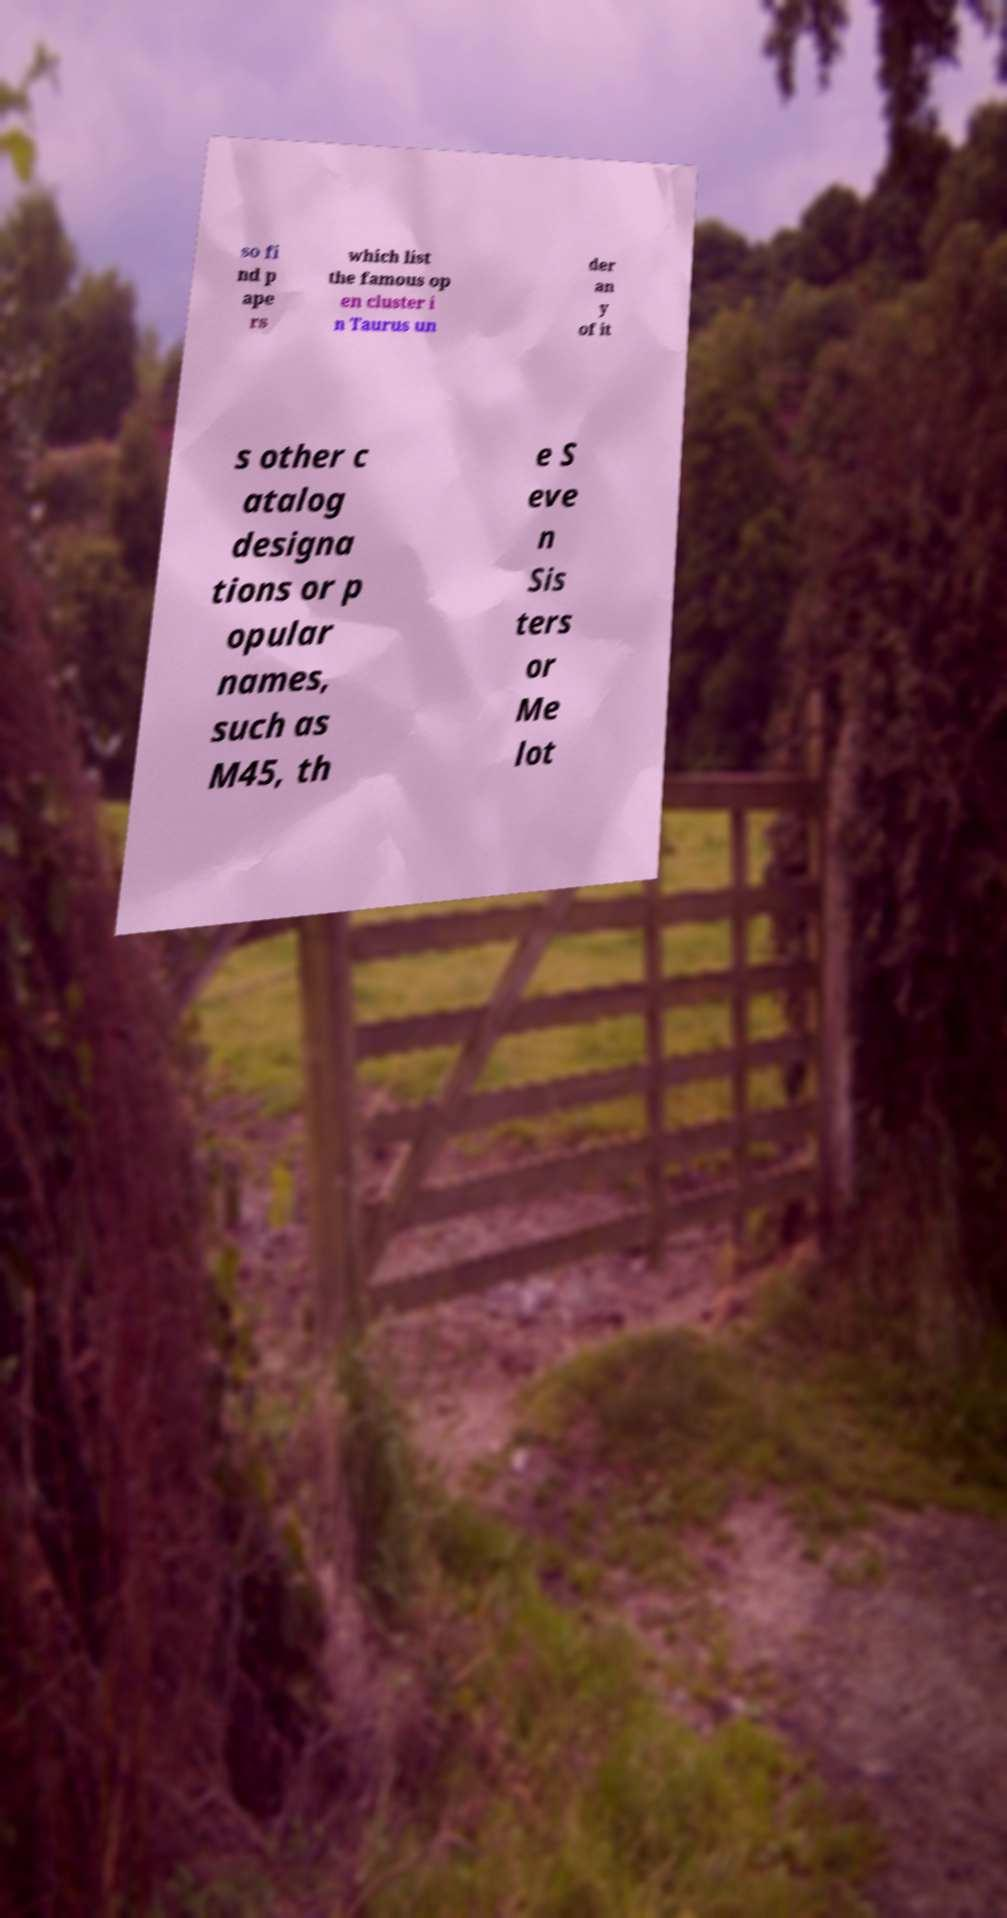Can you read and provide the text displayed in the image?This photo seems to have some interesting text. Can you extract and type it out for me? so fi nd p ape rs which list the famous op en cluster i n Taurus un der an y of it s other c atalog designa tions or p opular names, such as M45, th e S eve n Sis ters or Me lot 